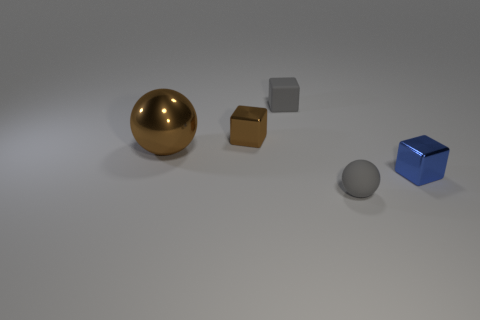Add 1 small brown blocks. How many objects exist? 6 Subtract all cubes. How many objects are left? 2 Add 1 brown metallic objects. How many brown metallic objects exist? 3 Subtract 0 cyan cubes. How many objects are left? 5 Subtract all brown cubes. Subtract all big red spheres. How many objects are left? 4 Add 2 tiny gray cubes. How many tiny gray cubes are left? 3 